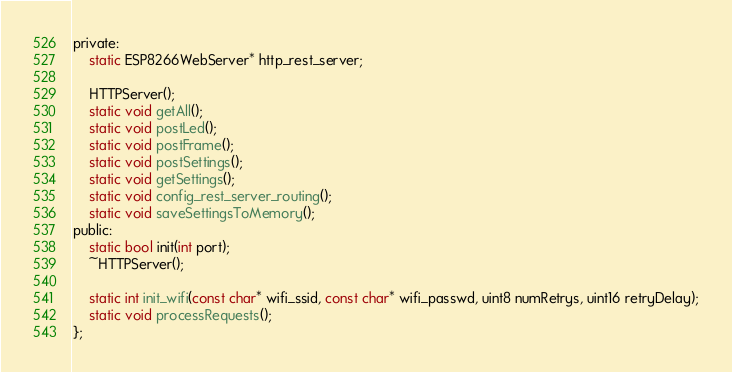Convert code to text. <code><loc_0><loc_0><loc_500><loc_500><_C_>private:
    static ESP8266WebServer* http_rest_server;

    HTTPServer();
    static void getAll();
    static void postLed();
    static void postFrame();
    static void postSettings();
    static void getSettings();
    static void config_rest_server_routing();
    static void saveSettingsToMemory();
public:
    static bool init(int port);
    ~HTTPServer();

    static int init_wifi(const char* wifi_ssid, const char* wifi_passwd, uint8 numRetrys, uint16 retryDelay);
    static void processRequests();
};</code> 